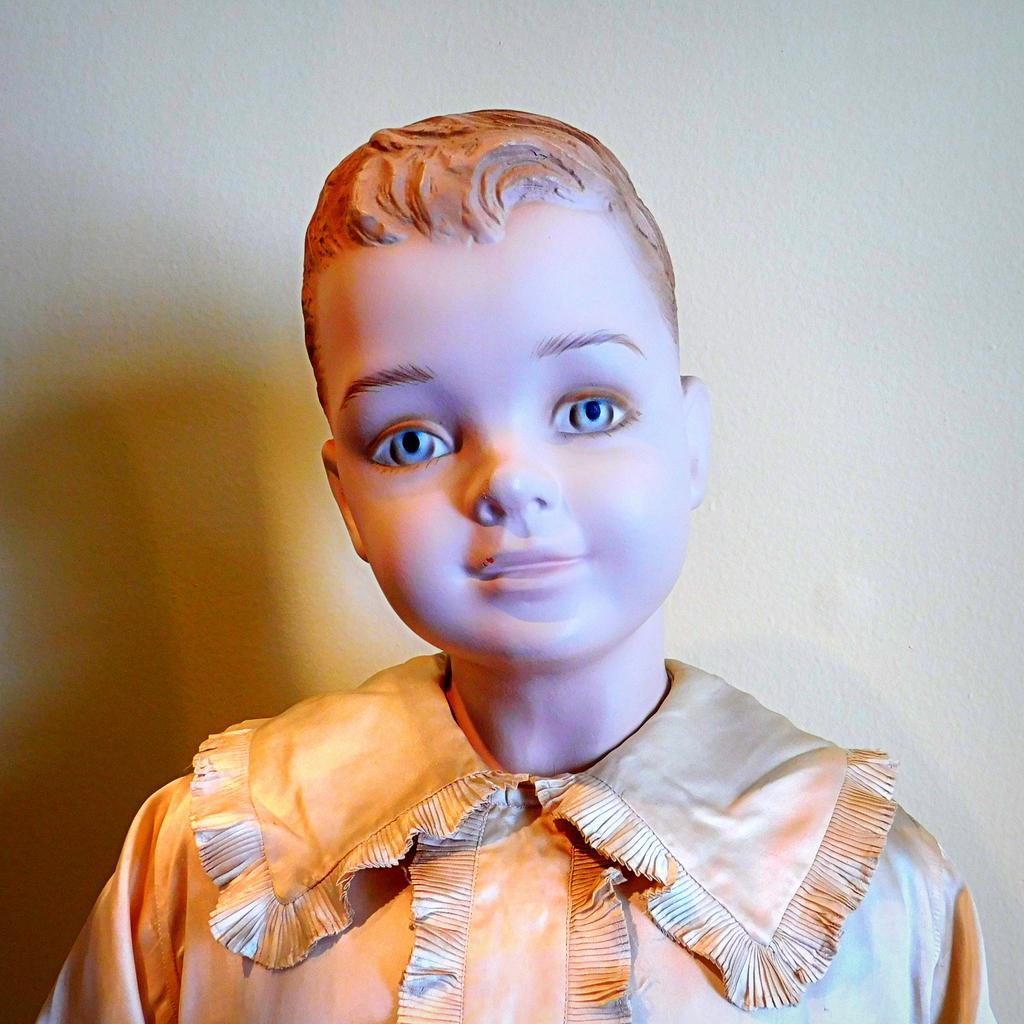Describe this image in one or two sentences. In this picture, we see the figurine of the boy who is wearing a gold dress. In the background, we see a wall in white color. On the left side, we see the shadow of the figurine. 